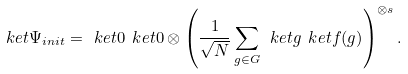<formula> <loc_0><loc_0><loc_500><loc_500>\ k e t { \Psi _ { i n i t } } = \ k e t { 0 } \ k e t { 0 } \otimes \left ( \frac { 1 } { \sqrt { N } } \sum _ { g \in G } \ k e t { g } \ k e t { f ( g ) } \right ) ^ { \otimes s } .</formula> 